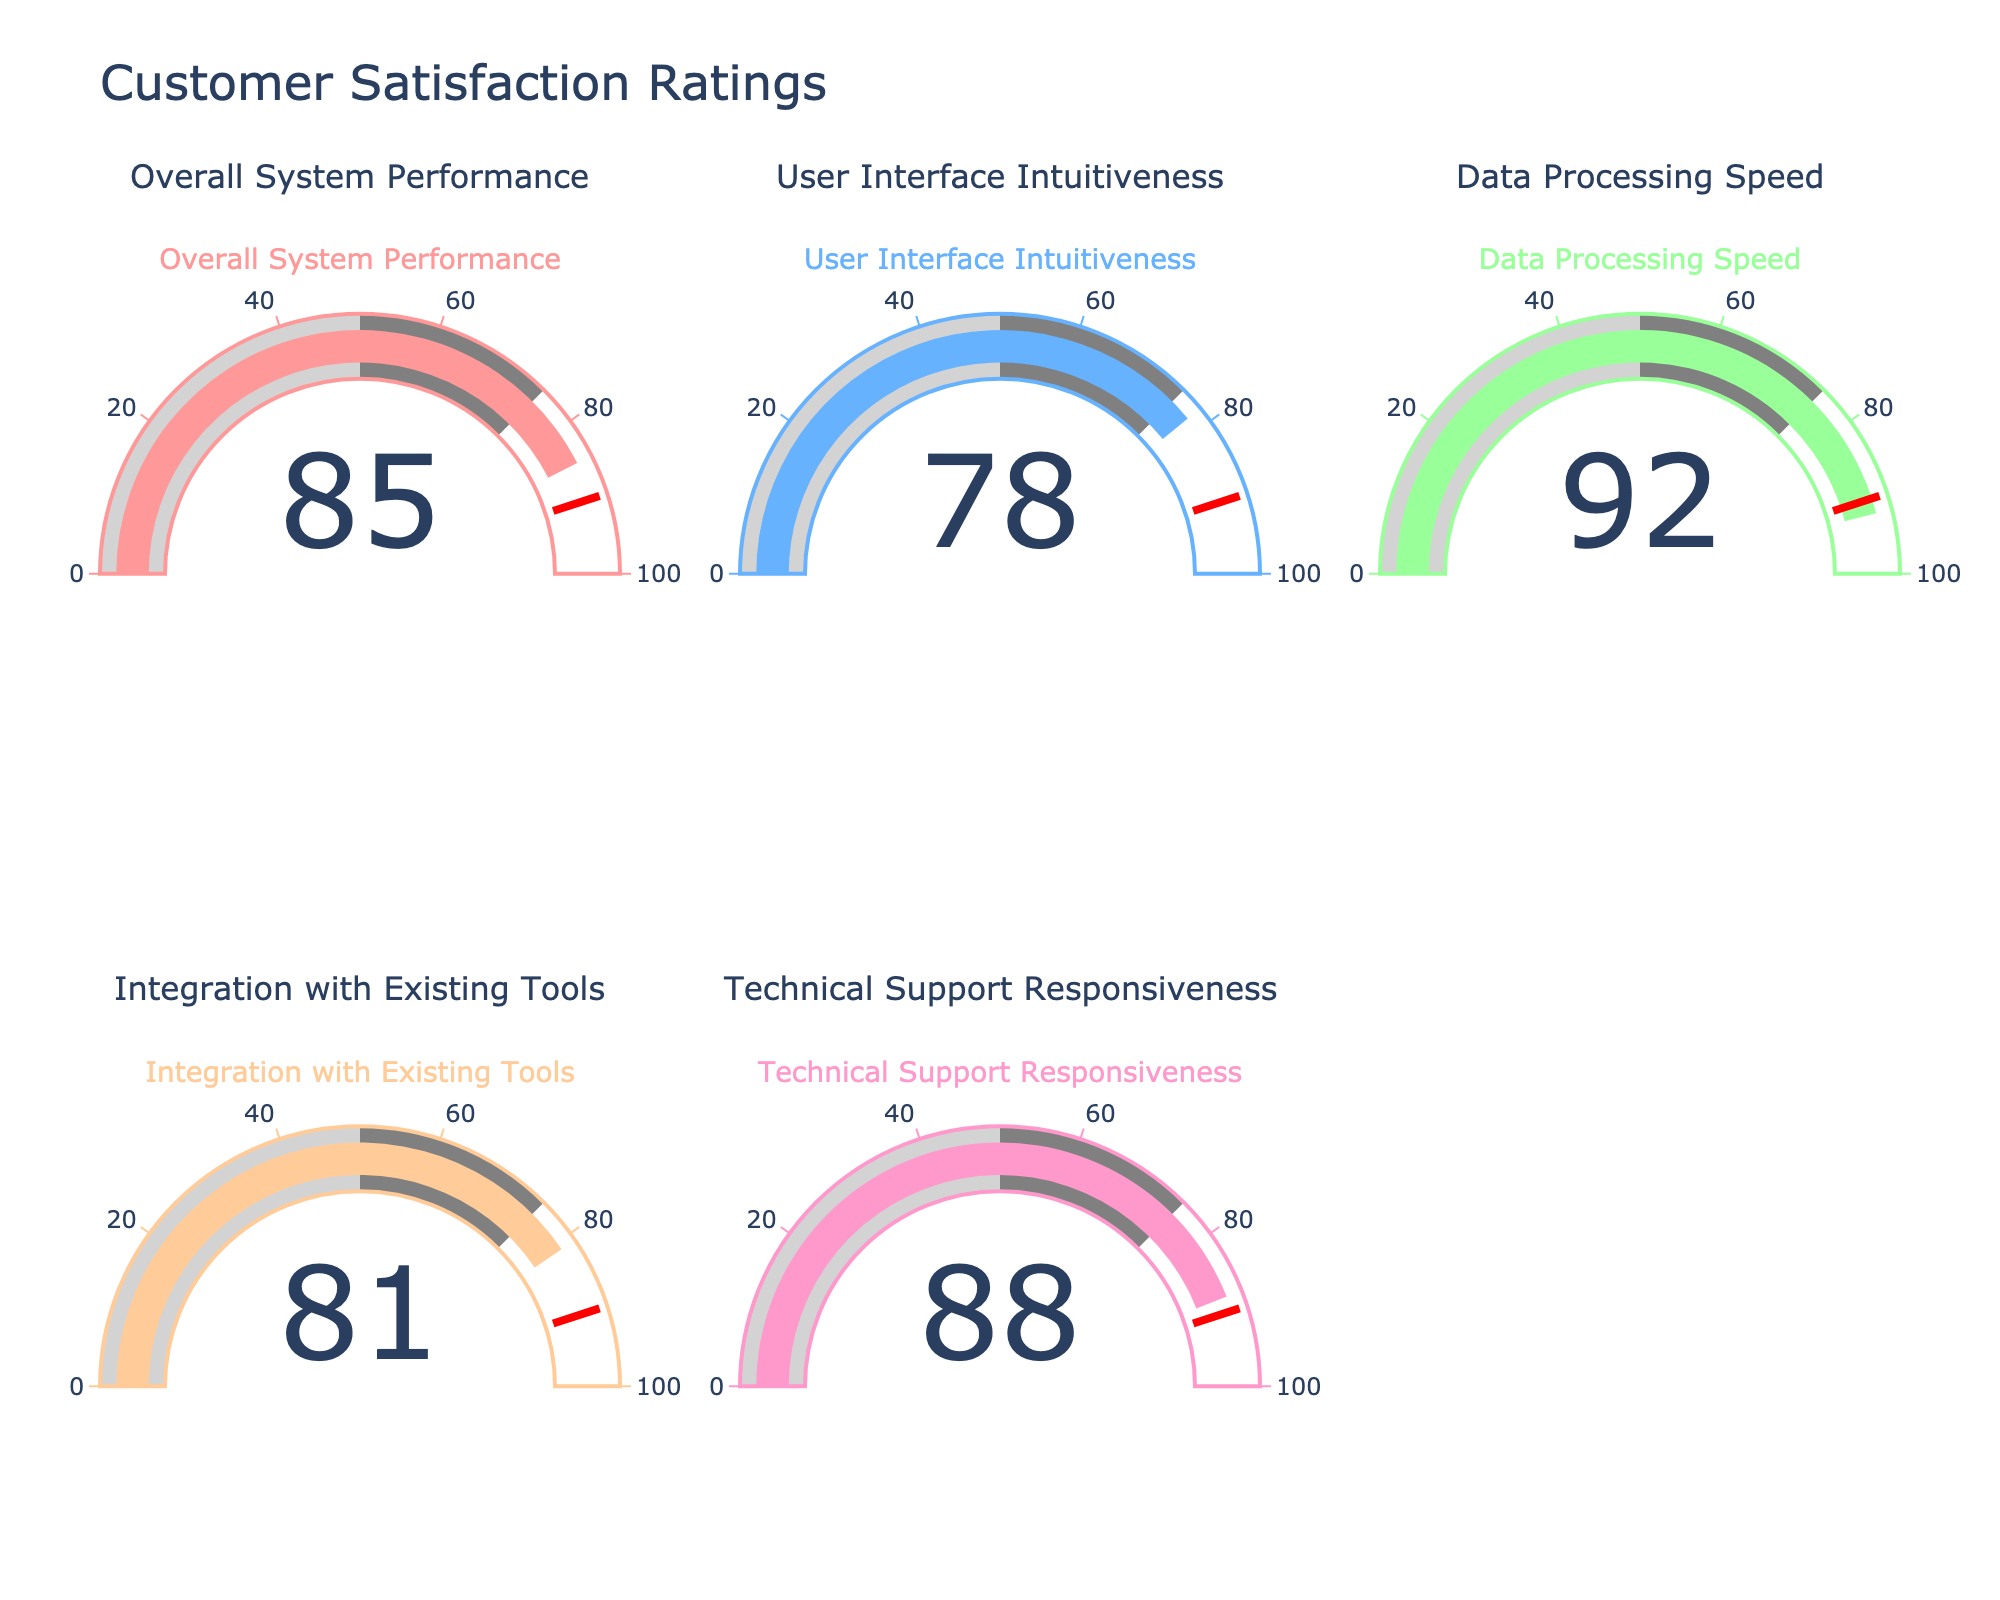What's the title of the figure? The title is always located at the top of the figure and provides a summary of the chart's content. It helps viewers quickly understand the context. In this case, the title is clearly displayed at the top.
Answer: "Customer Satisfaction Ratings" Which metric received the highest rating? To determine the highest rating, examine all the gauge charts to identify the one with the maximum value displayed. In this figure, the highest rating is visible in the "Data Processing Speed" gauge.
Answer: Data Processing Speed What is the rating for "Overall System Performance"? Locate the gauge chart titled "Overall System Performance" and observe the number displayed within the gauge. This number represents the rating for that metric.
Answer: 85 Compare the ratings for "User Interface Intuitiveness" and "Integration with Existing Tools". Which is higher? To compare the ratings, find the gauge charts for both "User Interface Intuitiveness" and "Integration with Existing Tools" and observe their values. The number displayed in "Integration with Existing Tools" is higher.
Answer: Integration with Existing Tools What is the average rating across all metrics? Add up all the ratings (85 + 78 + 92 + 81 + 88) and divide by the number of metrics (5) to compute the average.
Answer: (85 + 78 + 92 + 81 + 88) / 5 = 424 / 5 = 84.8 How many metrics have a rating greater than 80? Identify and count the gauges with ratings above 80: "Overall System Performance" (85), "Data Processing Speed" (92), "Integration with Existing Tools" (81), and "Technical Support Responsiveness" (88).
Answer: 4 Which metric is closest to the median rating? Arrange the ratings in ascending order (78, 81, 85, 88, 92) and identify the middle value, which is 85. Locate the metric with this rating.
Answer: Overall System Performance Is any metric rating below 80? Scan all the gauge values to identify if any are below 80. Only the "User Interface Intuitiveness" gauge shows a value below 80.
Answer: Yes, "User Interface Intuitiveness" Which metric has the closest rating to 90? Compare each gauge rating to the value 90 and determine which is closest. "Data Processing Speed" has a rating of 92, which is closest to 90.
Answer: Data Processing Speed What is the difference between the highest and lowest ratings? Subtract the lowest rating (78) from the highest rating (92) to calculate the difference.
Answer: 92 - 78 = 14 